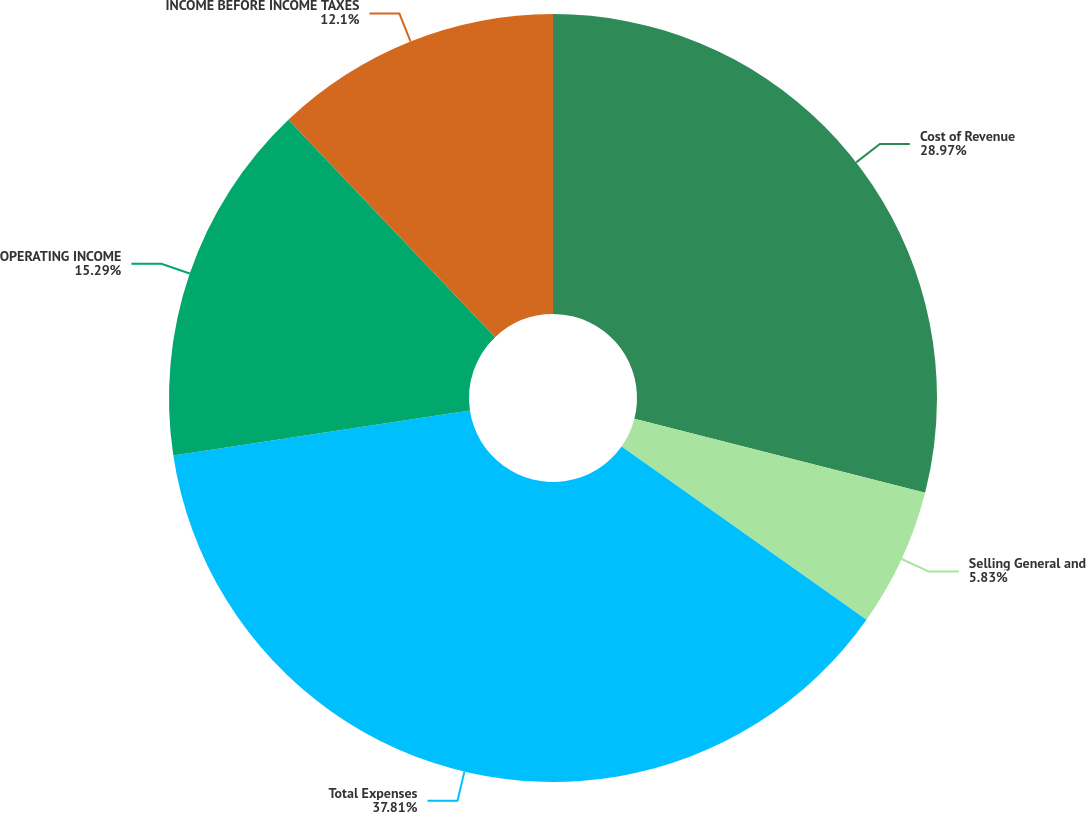Convert chart. <chart><loc_0><loc_0><loc_500><loc_500><pie_chart><fcel>Cost of Revenue<fcel>Selling General and<fcel>Total Expenses<fcel>OPERATING INCOME<fcel>INCOME BEFORE INCOME TAXES<nl><fcel>28.97%<fcel>5.83%<fcel>37.81%<fcel>15.29%<fcel>12.1%<nl></chart> 